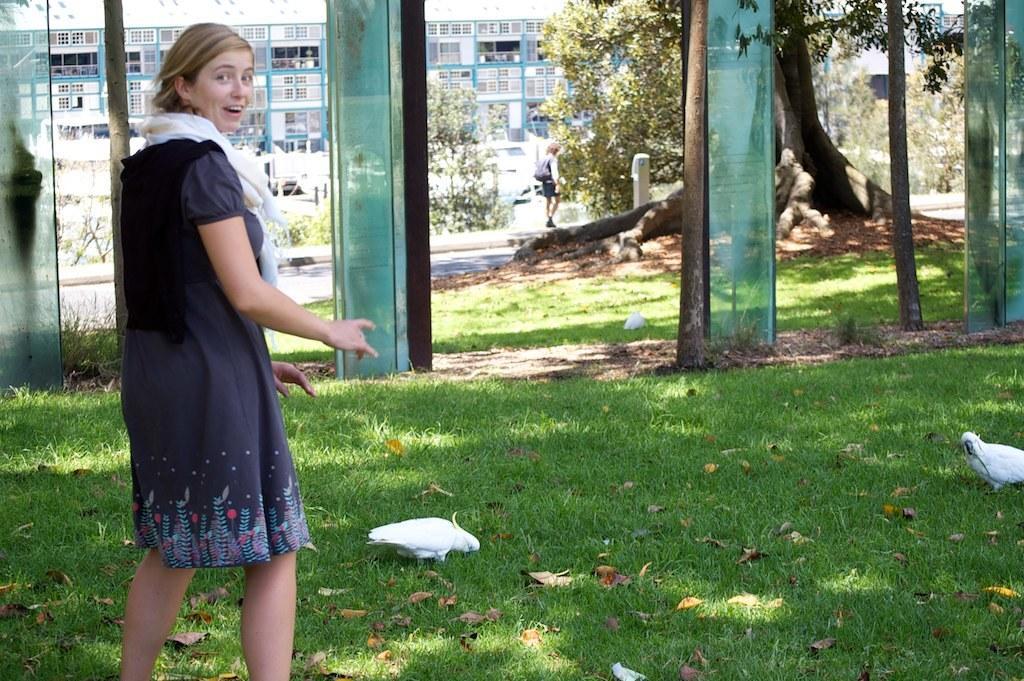In one or two sentences, can you explain what this image depicts? In this picture we can see there are two people walking. Behind the women there are glasses, trees and it looks like a building. On the grass there are two white birds. 